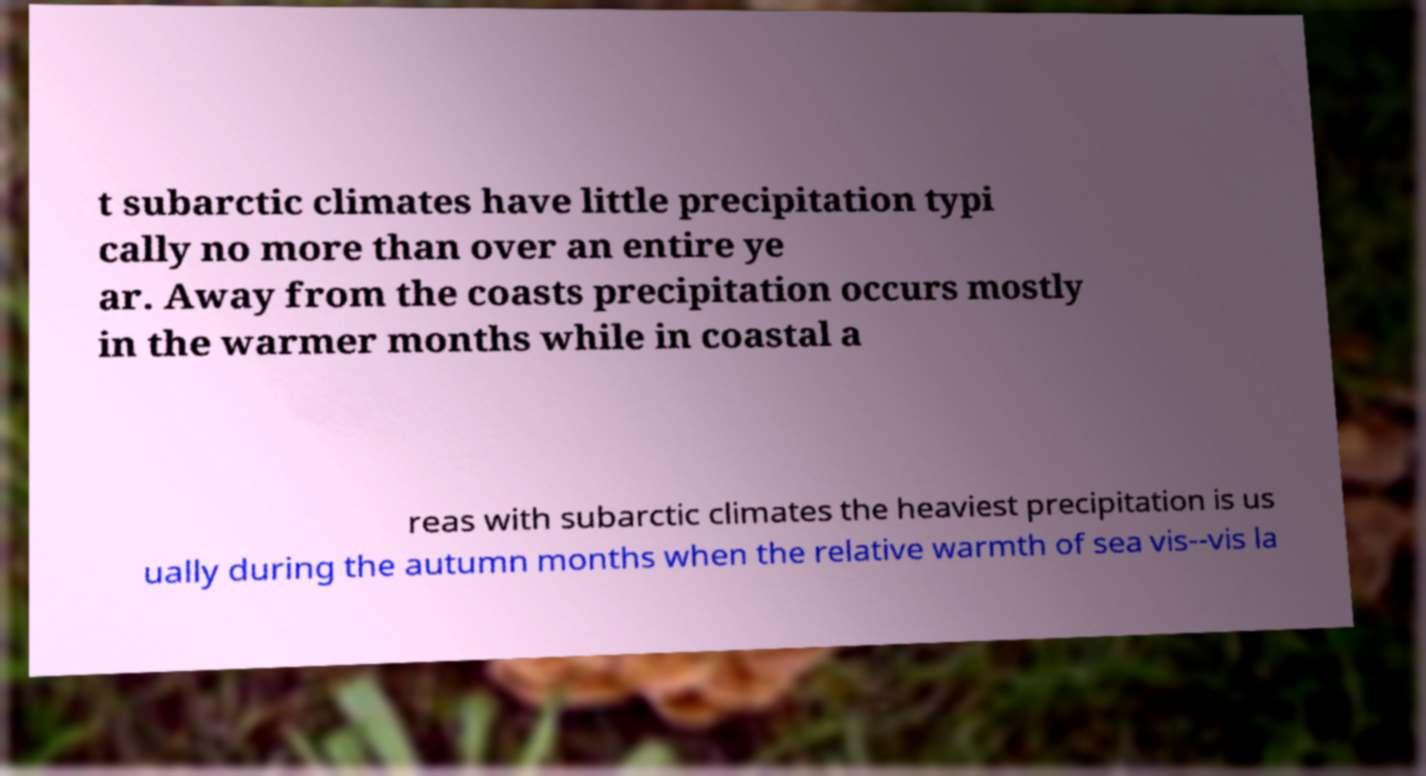Can you accurately transcribe the text from the provided image for me? t subarctic climates have little precipitation typi cally no more than over an entire ye ar. Away from the coasts precipitation occurs mostly in the warmer months while in coastal a reas with subarctic climates the heaviest precipitation is us ually during the autumn months when the relative warmth of sea vis--vis la 